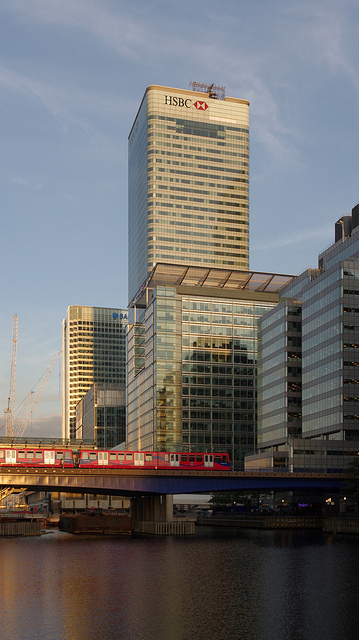Please transcribe the text in this image. HSBC 